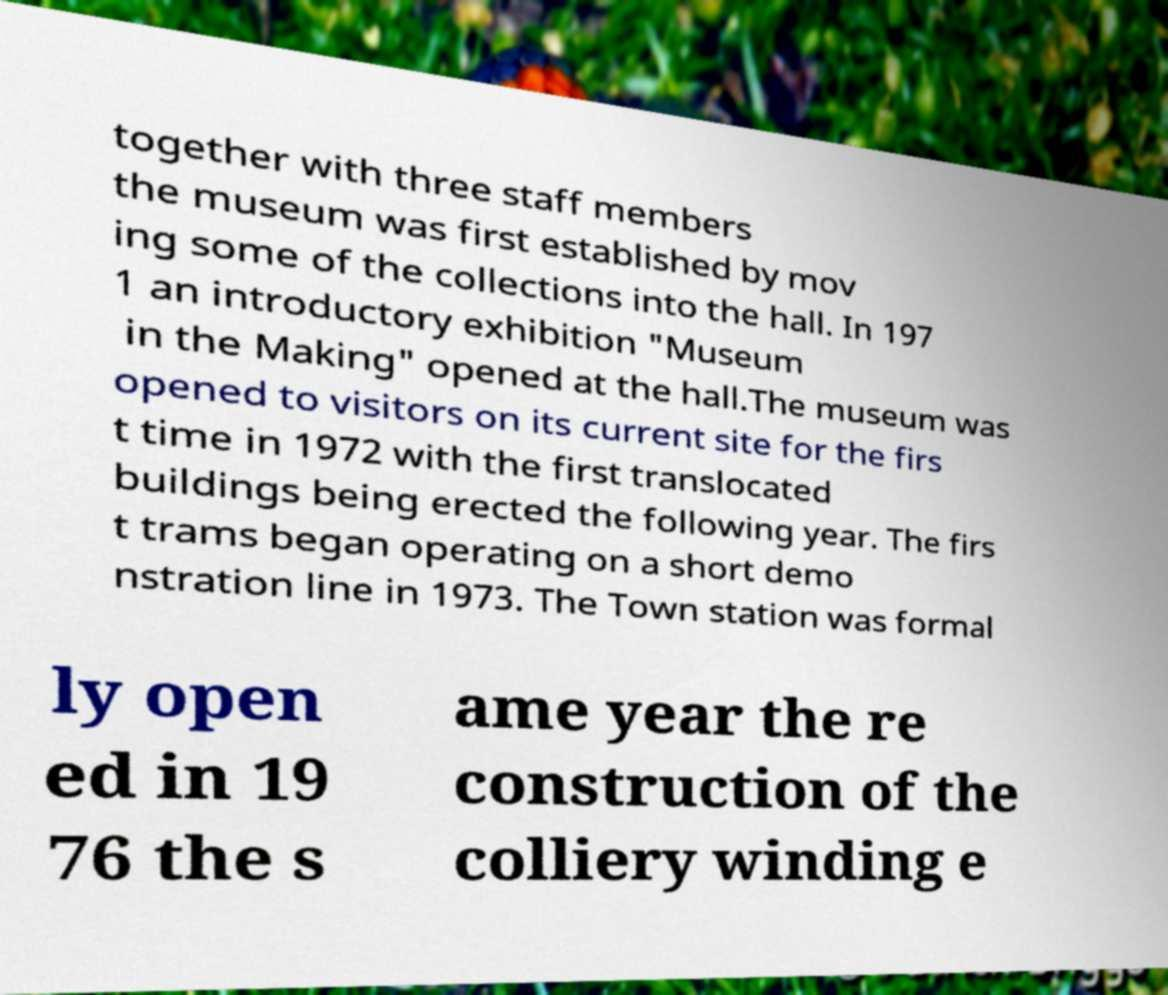Can you accurately transcribe the text from the provided image for me? together with three staff members the museum was first established by mov ing some of the collections into the hall. In 197 1 an introductory exhibition "Museum in the Making" opened at the hall.The museum was opened to visitors on its current site for the firs t time in 1972 with the first translocated buildings being erected the following year. The firs t trams began operating on a short demo nstration line in 1973. The Town station was formal ly open ed in 19 76 the s ame year the re construction of the colliery winding e 